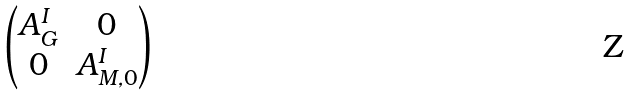<formula> <loc_0><loc_0><loc_500><loc_500>\begin{pmatrix} A ^ { I } _ { G } & 0 \\ 0 & A ^ { I } _ { M , 0 } \end{pmatrix}</formula> 